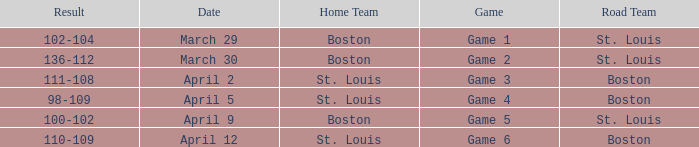Write the full table. {'header': ['Result', 'Date', 'Home Team', 'Game', 'Road Team'], 'rows': [['102-104', 'March 29', 'Boston', 'Game 1', 'St. Louis'], ['136-112', 'March 30', 'Boston', 'Game 2', 'St. Louis'], ['111-108', 'April 2', 'St. Louis', 'Game 3', 'Boston'], ['98-109', 'April 5', 'St. Louis', 'Game 4', 'Boston'], ['100-102', 'April 9', 'Boston', 'Game 5', 'St. Louis'], ['110-109', 'April 12', 'St. Louis', 'Game 6', 'Boston']]} What is the Game number on March 30? Game 2. 